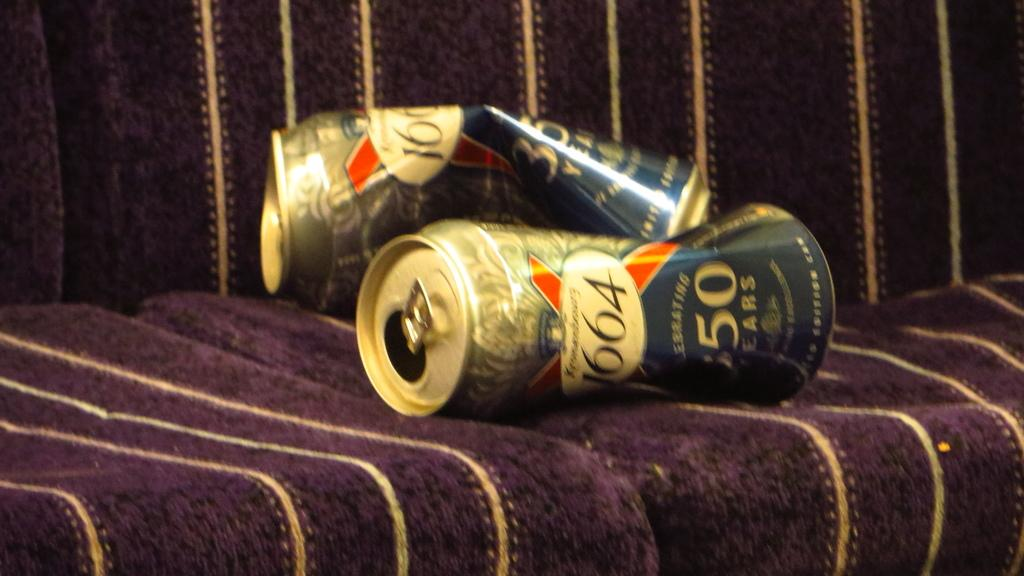<image>
Give a short and clear explanation of the subsequent image. two squished cans that say '1664' on them 